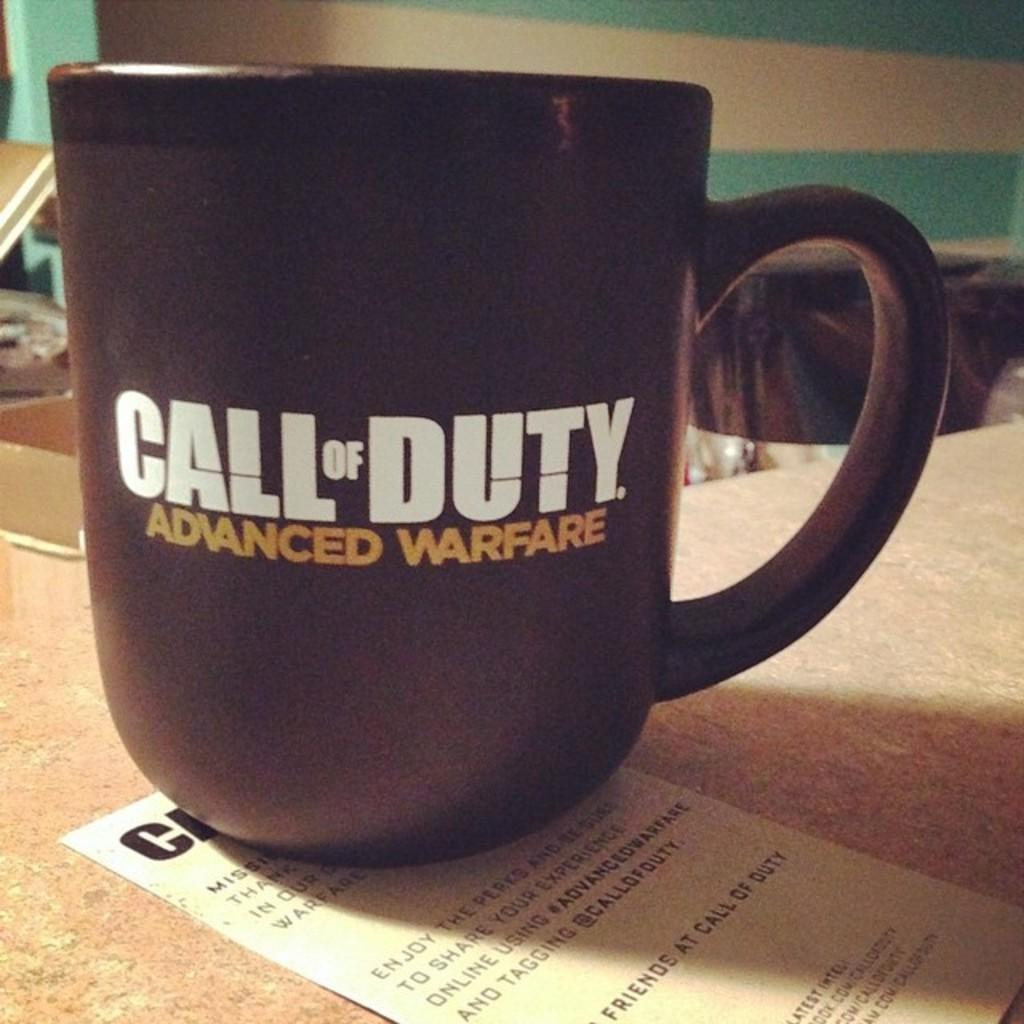<image>
Relay a brief, clear account of the picture shown. a call of duty advanced warfare black coffee mug 